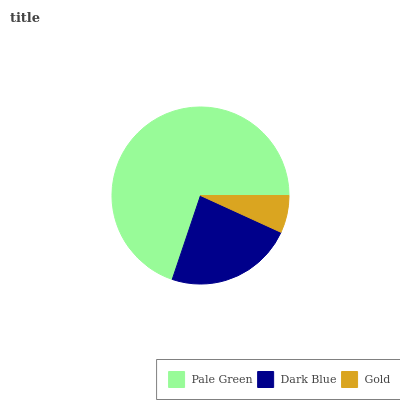Is Gold the minimum?
Answer yes or no. Yes. Is Pale Green the maximum?
Answer yes or no. Yes. Is Dark Blue the minimum?
Answer yes or no. No. Is Dark Blue the maximum?
Answer yes or no. No. Is Pale Green greater than Dark Blue?
Answer yes or no. Yes. Is Dark Blue less than Pale Green?
Answer yes or no. Yes. Is Dark Blue greater than Pale Green?
Answer yes or no. No. Is Pale Green less than Dark Blue?
Answer yes or no. No. Is Dark Blue the high median?
Answer yes or no. Yes. Is Dark Blue the low median?
Answer yes or no. Yes. Is Pale Green the high median?
Answer yes or no. No. Is Gold the low median?
Answer yes or no. No. 